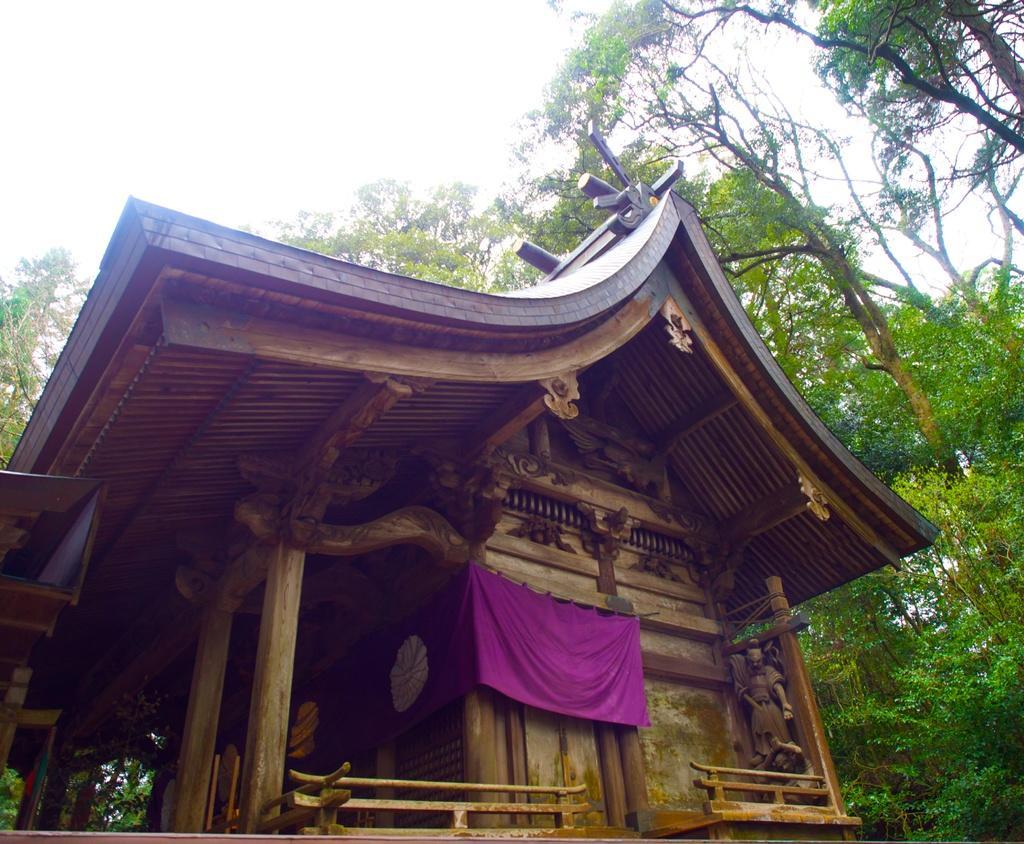Can you describe this image briefly? In the center of the image there is a shed and we can see sculptures carved on the shed. There is a flag. In the background there are trees and sky. 